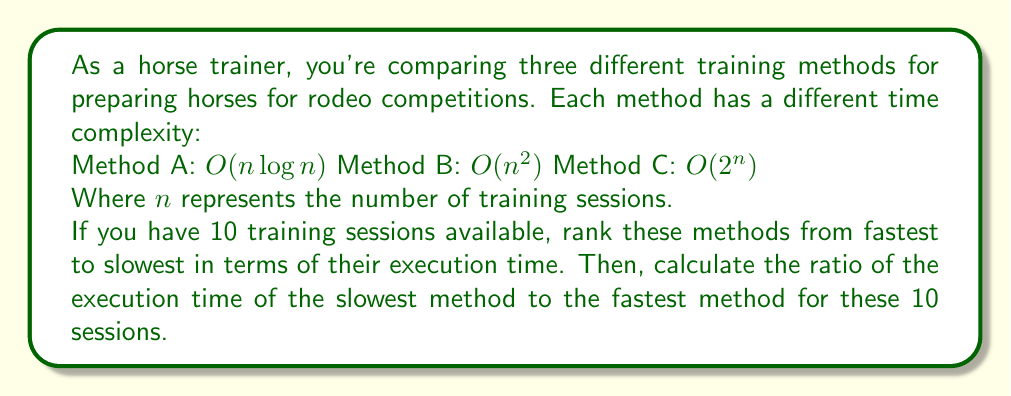Give your solution to this math problem. To solve this problem, we need to follow these steps:

1. Evaluate each method's time complexity for $n = 10$:

   Method A: $O(n \log n) = O(10 \log 10) \approx O(33.22)$
   Method B: $O(n^2) = O(10^2) = O(100)$
   Method C: $O(2^n) = O(2^{10}) = O(1024)$

2. Rank the methods from fastest to slowest:
   Method A < Method B < Method C

3. Calculate the ratio of the slowest to the fastest:

   Ratio = $\frac{\text{Slowest}}{\text{Fastest}} = \frac{O(2^{10})}{O(10 \log 10)} = \frac{1024}{33.22} \approx 30.83$

Note that we're using the actual values instead of just the order of magnitude for a more precise ratio. In practice, the constant factors and lower-order terms that big O notation ignores could affect the actual running times, but this gives us a good approximation for comparison.
Answer: Ranking from fastest to slowest: Method A, Method B, Method C
Ratio of slowest to fastest: approximately 30.83 